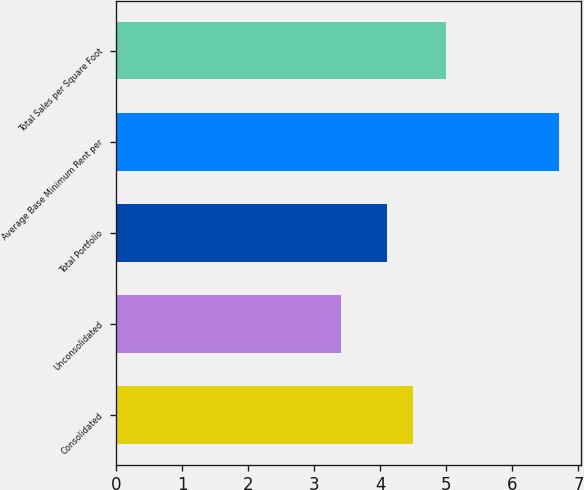Convert chart. <chart><loc_0><loc_0><loc_500><loc_500><bar_chart><fcel>Consolidated<fcel>Unconsolidated<fcel>Total Portfolio<fcel>Average Base Minimum Rent per<fcel>Total Sales per Square Foot<nl><fcel>4.5<fcel>3.4<fcel>4.1<fcel>6.7<fcel>5<nl></chart> 